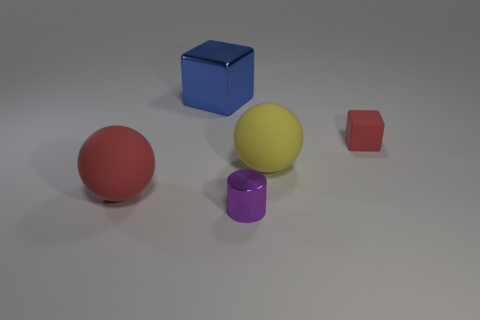The large object that is in front of the tiny red rubber cube and left of the small purple thing is made of what material?
Provide a short and direct response. Rubber. How many matte things have the same shape as the purple metal object?
Provide a short and direct response. 0. What is the object that is behind the tiny red cube made of?
Provide a succinct answer. Metal. Are there fewer blue metallic blocks that are to the right of the purple cylinder than big blue metal objects?
Make the answer very short. Yes. Does the small metallic object have the same shape as the small matte thing?
Provide a succinct answer. No. Are there any other things that are the same shape as the tiny purple thing?
Offer a terse response. No. Are there any red rubber blocks?
Your answer should be very brief. Yes. There is a blue object; is it the same shape as the big matte object left of the large cube?
Make the answer very short. No. There is a tiny thing that is in front of the red matte thing to the left of the tiny cylinder; what is it made of?
Offer a very short reply. Metal. The tiny block has what color?
Keep it short and to the point. Red. 